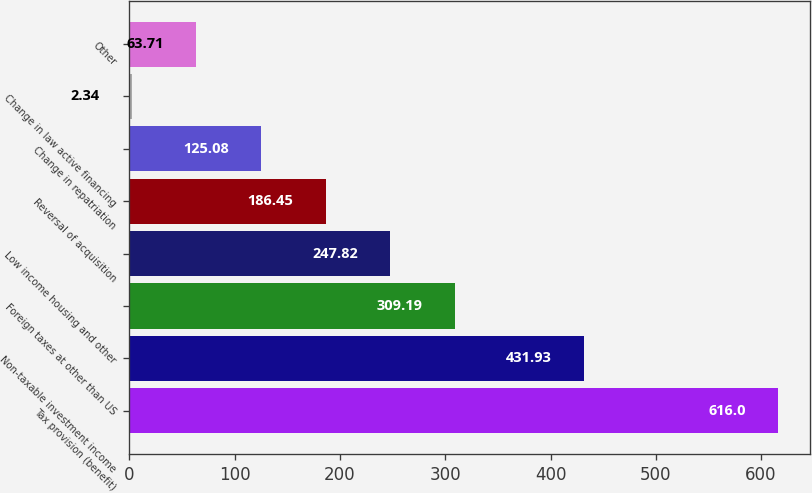Convert chart to OTSL. <chart><loc_0><loc_0><loc_500><loc_500><bar_chart><fcel>Tax provision (benefit)<fcel>Non-taxable investment income<fcel>Foreign taxes at other than US<fcel>Low income housing and other<fcel>Reversal of acquisition<fcel>Change in repatriation<fcel>Change in law active financing<fcel>Other<nl><fcel>616<fcel>431.93<fcel>309.19<fcel>247.82<fcel>186.45<fcel>125.08<fcel>2.34<fcel>63.71<nl></chart> 